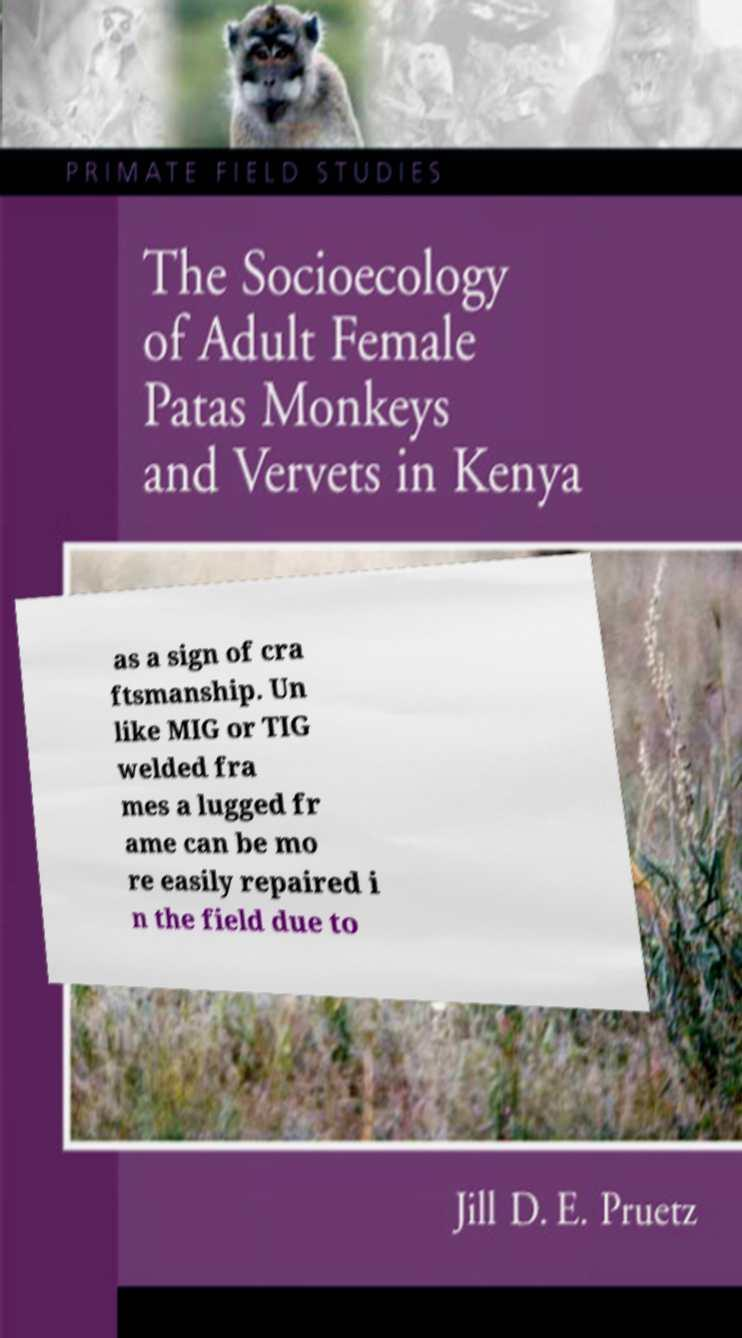For documentation purposes, I need the text within this image transcribed. Could you provide that? as a sign of cra ftsmanship. Un like MIG or TIG welded fra mes a lugged fr ame can be mo re easily repaired i n the field due to 